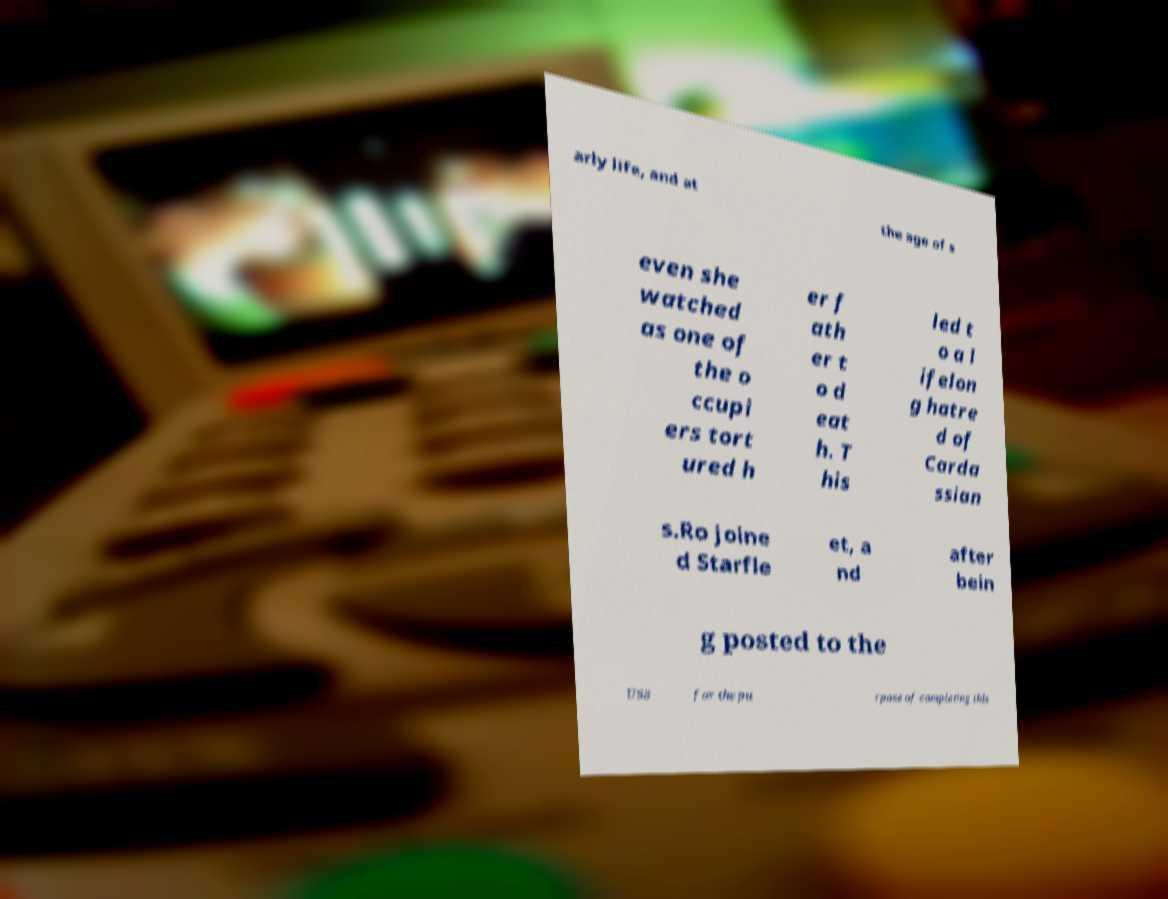I need the written content from this picture converted into text. Can you do that? arly life, and at the age of s even she watched as one of the o ccupi ers tort ured h er f ath er t o d eat h. T his led t o a l ifelon g hatre d of Carda ssian s.Ro joine d Starfle et, a nd after bein g posted to the USS for the pu rpose of completing this 